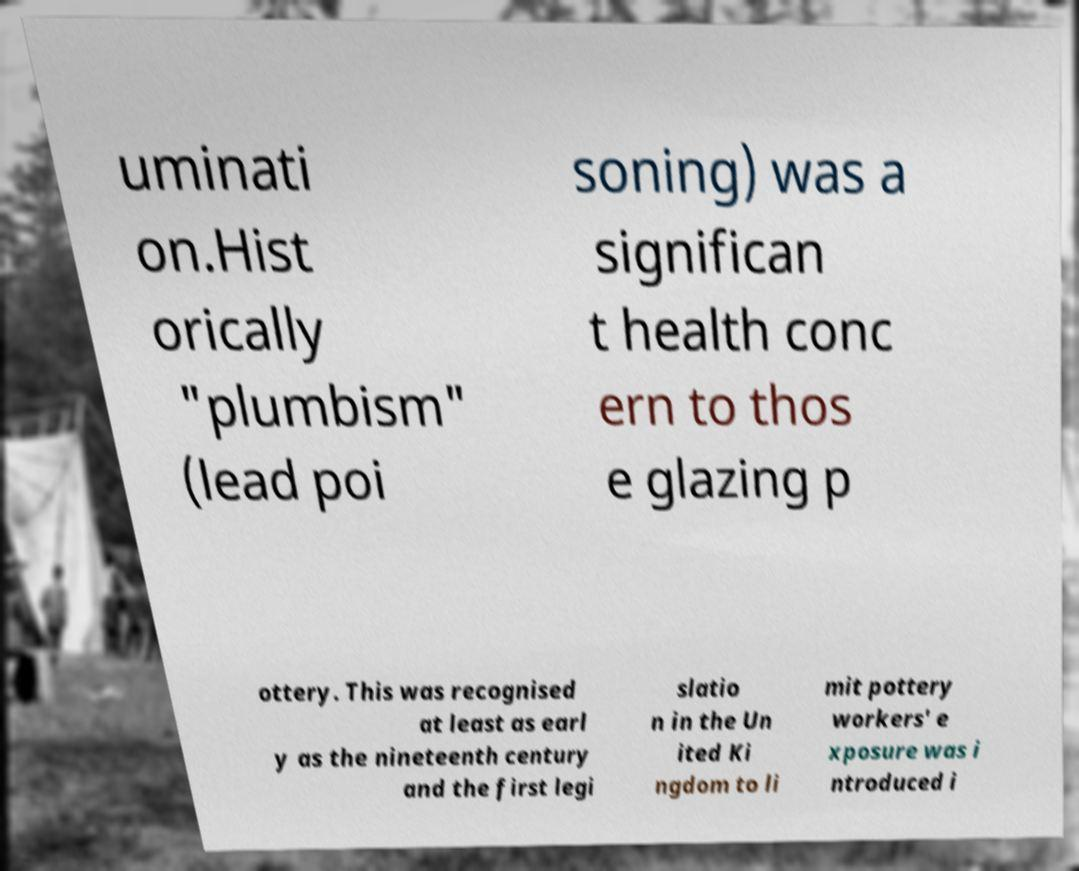Could you extract and type out the text from this image? uminati on.Hist orically "plumbism" (lead poi soning) was a significan t health conc ern to thos e glazing p ottery. This was recognised at least as earl y as the nineteenth century and the first legi slatio n in the Un ited Ki ngdom to li mit pottery workers' e xposure was i ntroduced i 